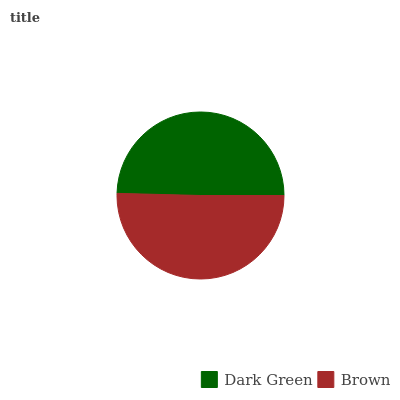Is Dark Green the minimum?
Answer yes or no. Yes. Is Brown the maximum?
Answer yes or no. Yes. Is Brown the minimum?
Answer yes or no. No. Is Brown greater than Dark Green?
Answer yes or no. Yes. Is Dark Green less than Brown?
Answer yes or no. Yes. Is Dark Green greater than Brown?
Answer yes or no. No. Is Brown less than Dark Green?
Answer yes or no. No. Is Brown the high median?
Answer yes or no. Yes. Is Dark Green the low median?
Answer yes or no. Yes. Is Dark Green the high median?
Answer yes or no. No. Is Brown the low median?
Answer yes or no. No. 